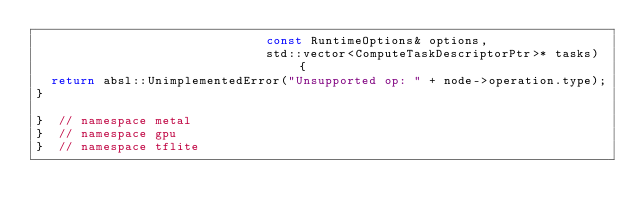<code> <loc_0><loc_0><loc_500><loc_500><_C++_>                               const RuntimeOptions& options,
                               std::vector<ComputeTaskDescriptorPtr>* tasks) {
  return absl::UnimplementedError("Unsupported op: " + node->operation.type);
}

}  // namespace metal
}  // namespace gpu
}  // namespace tflite
</code> 